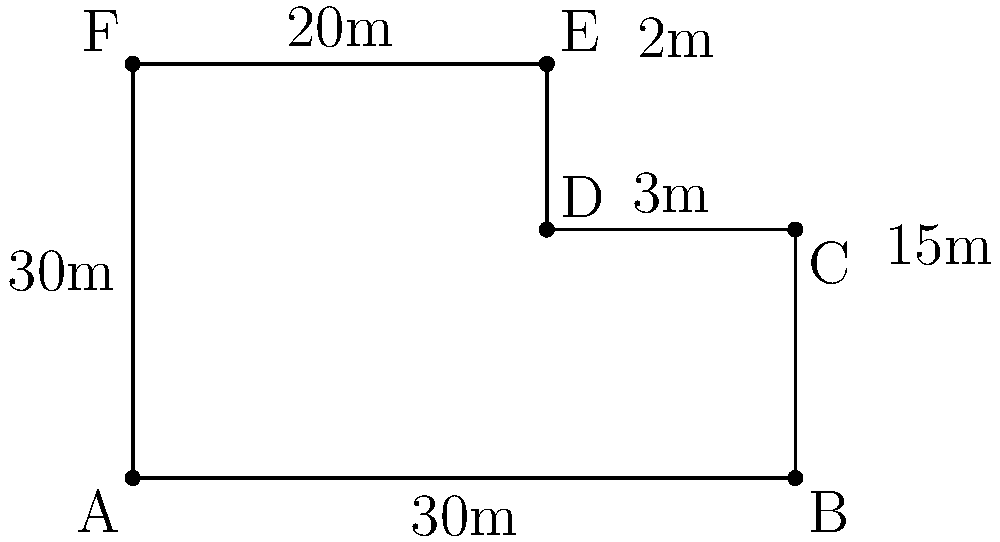As a community outreach coordinator, you're planning a neighborhood block party. The party area consists of two connected rectangular spaces, as shown in the diagram. Calculate the perimeter of the entire party area in meters. To calculate the perimeter of the entire party area, we need to sum up all the outer sides of the shape. Let's break it down step by step:

1. Identify the outer sides of the shape:
   - Bottom side (AB): 30m
   - Right side (BC + CD): 15m + 3m = 18m
   - Top right side (DE): 2m
   - Top side (EF): 20m
   - Left side (FA): 30m

2. Sum up all these sides:
   $$ \text{Perimeter} = 30m + 18m + 2m + 20m + 30m $$

3. Calculate the total:
   $$ \text{Perimeter} = 100m $$

Therefore, the perimeter of the entire party area is 100 meters.
Answer: 100m 